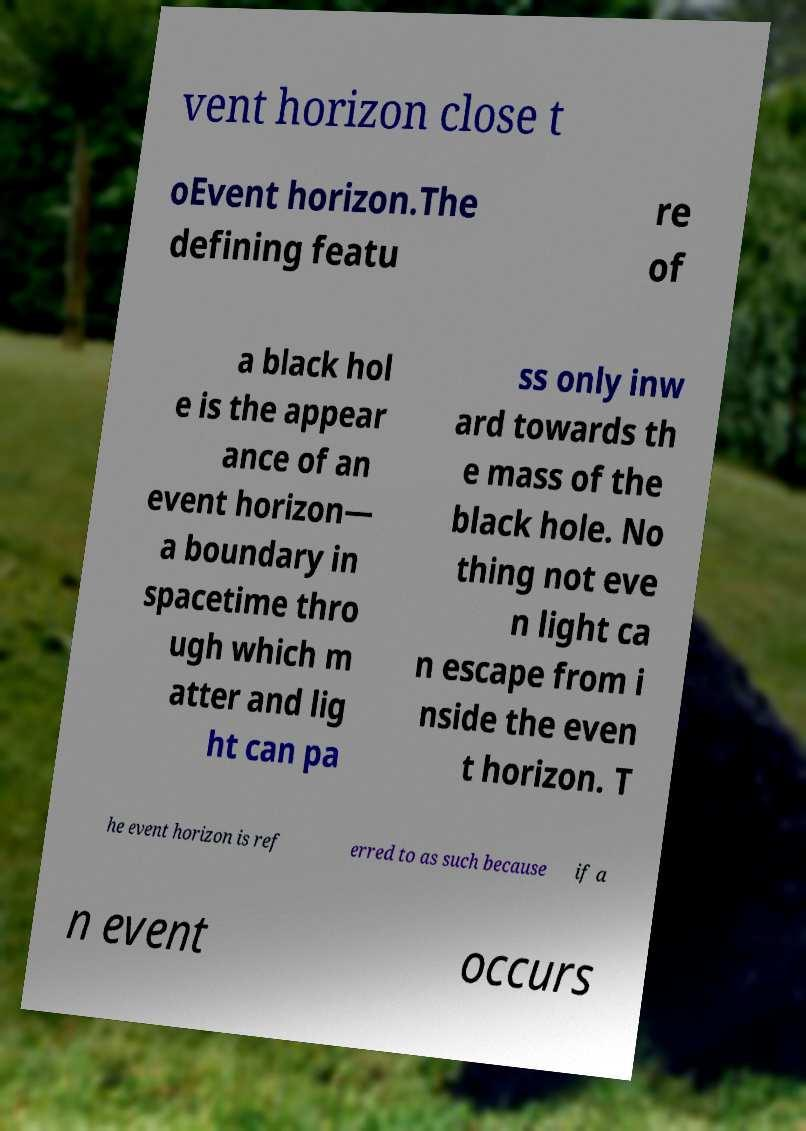Could you assist in decoding the text presented in this image and type it out clearly? vent horizon close t oEvent horizon.The defining featu re of a black hol e is the appear ance of an event horizon— a boundary in spacetime thro ugh which m atter and lig ht can pa ss only inw ard towards th e mass of the black hole. No thing not eve n light ca n escape from i nside the even t horizon. T he event horizon is ref erred to as such because if a n event occurs 